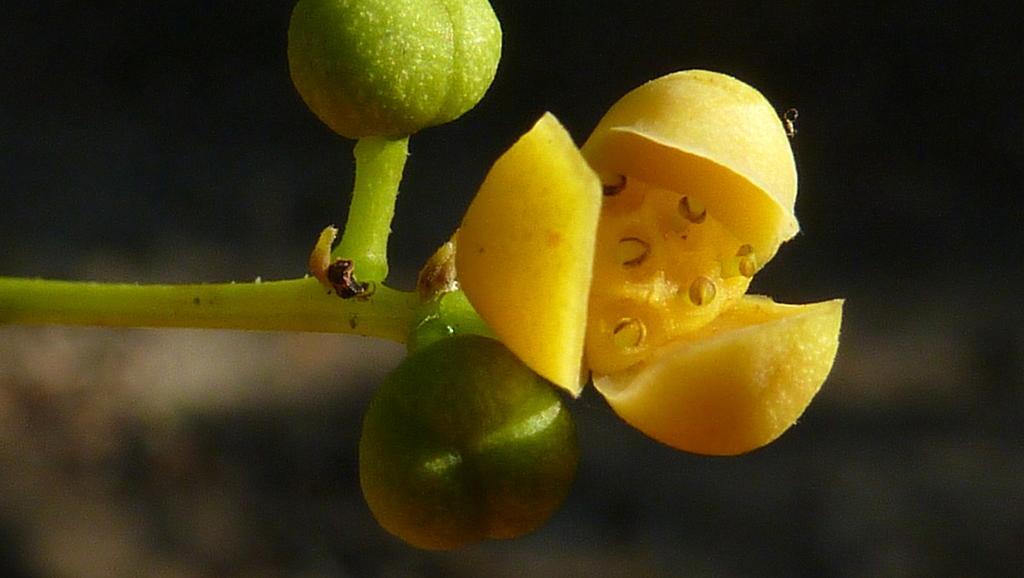Please provide a concise description of this image. There is a flower, stem and buds in the foreground area of the image and the background is blurry. 